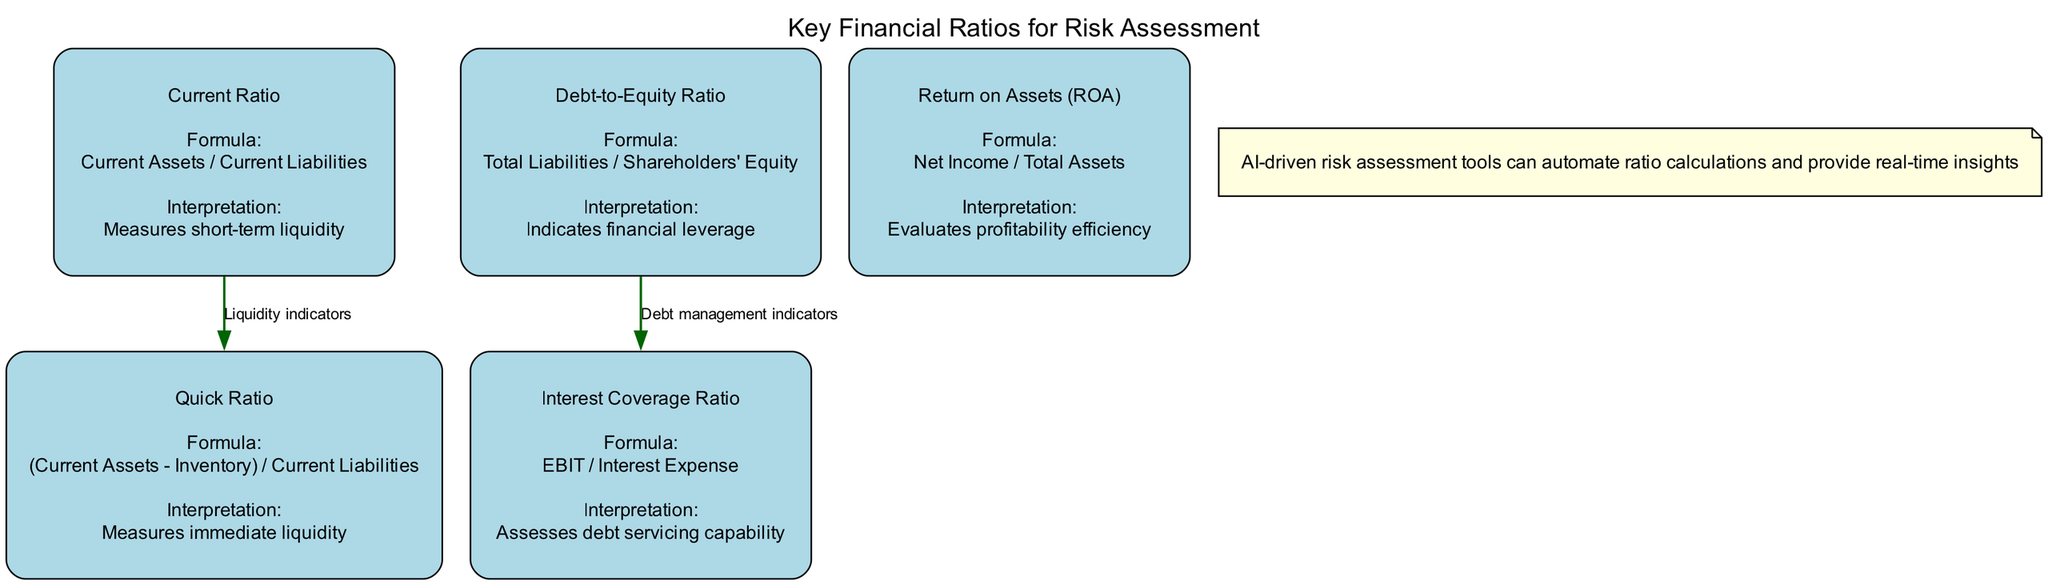What is the formula for the Current Ratio? The diagram contains the "Current Ratio" node, which includes the formula information. It states that the formula is "Current Assets / Current Liabilities".
Answer: Current Assets / Current Liabilities What does the Interest Coverage Ratio assess? Looking at the "Interest Coverage Ratio" node, the interpretation provided states that it "Assesses debt servicing capability".
Answer: Assess debt servicing capability How many financial ratios are represented in the diagram? By counting the number of nodes that are categorized as ratios within the diagram, there are a total of 5 ratios depicted.
Answer: 5 Which two ratios are connected by the label "Debt management indicators"? The diagram shows a connection from "Debt-to-Equity Ratio" to "Interest Coverage Ratio" with the label "Debt management indicators", indicating the relationship between these two ratios.
Answer: Debt-to-Equity Ratio and Interest Coverage Ratio What is the interpretation of Return on Assets (ROA)? The "Return on Assets (ROA)" node provides an interpretation that it "Evaluates profitability efficiency". This reveals the purpose of this financial ratio.
Answer: Evaluates profitability efficiency What do the Current Ratio and Quick Ratio have in common? The diagram shows that both ratios are labeled under a connection of "Liquidity indicators", indicating that they are both related to assessing liquidity.
Answer: Liquidity indicators What type of assessment can AI-driven tools provide based on the note? The note states that "AI-driven risk assessment tools can automate ratio calculations and provide real-time insights", indicating the type of assessment they can provide.
Answer: Automated ratio calculations and real-time insights What is the visual shape of the ratio nodes in the diagram? Each ratio node in the diagram is represented using a "box" shape with styles such as rounded and filled, as mentioned in the node configurations.
Answer: Box What is the primary focus of the diagram? The title of the diagram, "Key Financial Ratios for Risk Assessment", clearly indicates that its primary focus is on financial ratios used in risk assessment.
Answer: Financial ratios for risk assessment 